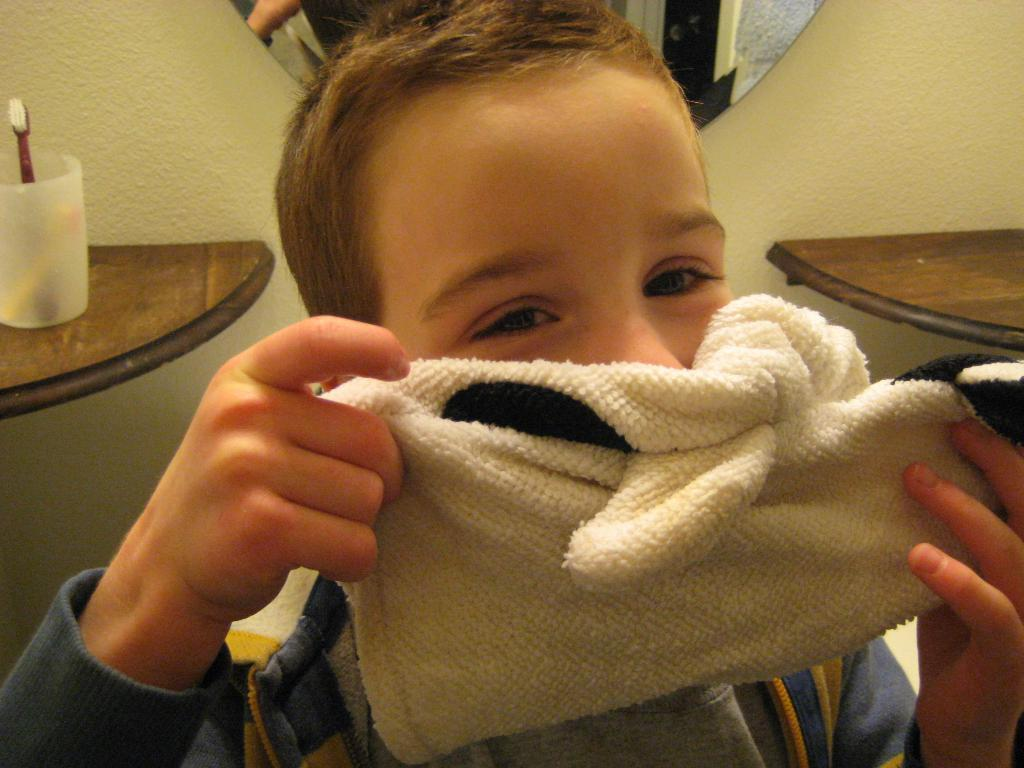Who is present in the image? There is a boy in the image. What is the boy holding in the image? The boy is holding a cloth in the image. What can be seen on the wall in the image? There is a mirror on the wall in the image. What type of furniture is present in the image? There are wooden shelves in the image. What item related to personal hygiene can be seen on the shelf? There is a toothbrush in a glass on the shelf in the image. What type of coil is visible in the image? There is no coil present in the image. How does the mirror crack in the image? The mirror does not crack in the image; it is intact. 